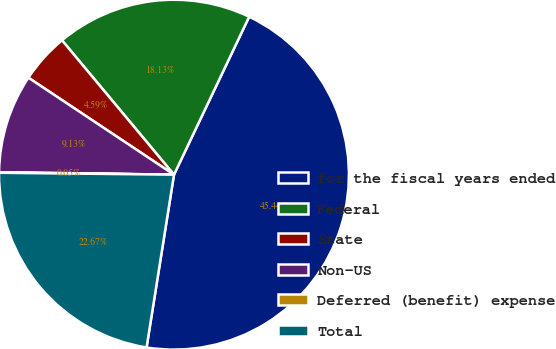<chart> <loc_0><loc_0><loc_500><loc_500><pie_chart><fcel>for the fiscal years ended<fcel>Federal<fcel>State<fcel>Non-US<fcel>Deferred (benefit) expense<fcel>Total<nl><fcel>45.44%<fcel>18.13%<fcel>4.59%<fcel>9.13%<fcel>0.05%<fcel>22.67%<nl></chart> 